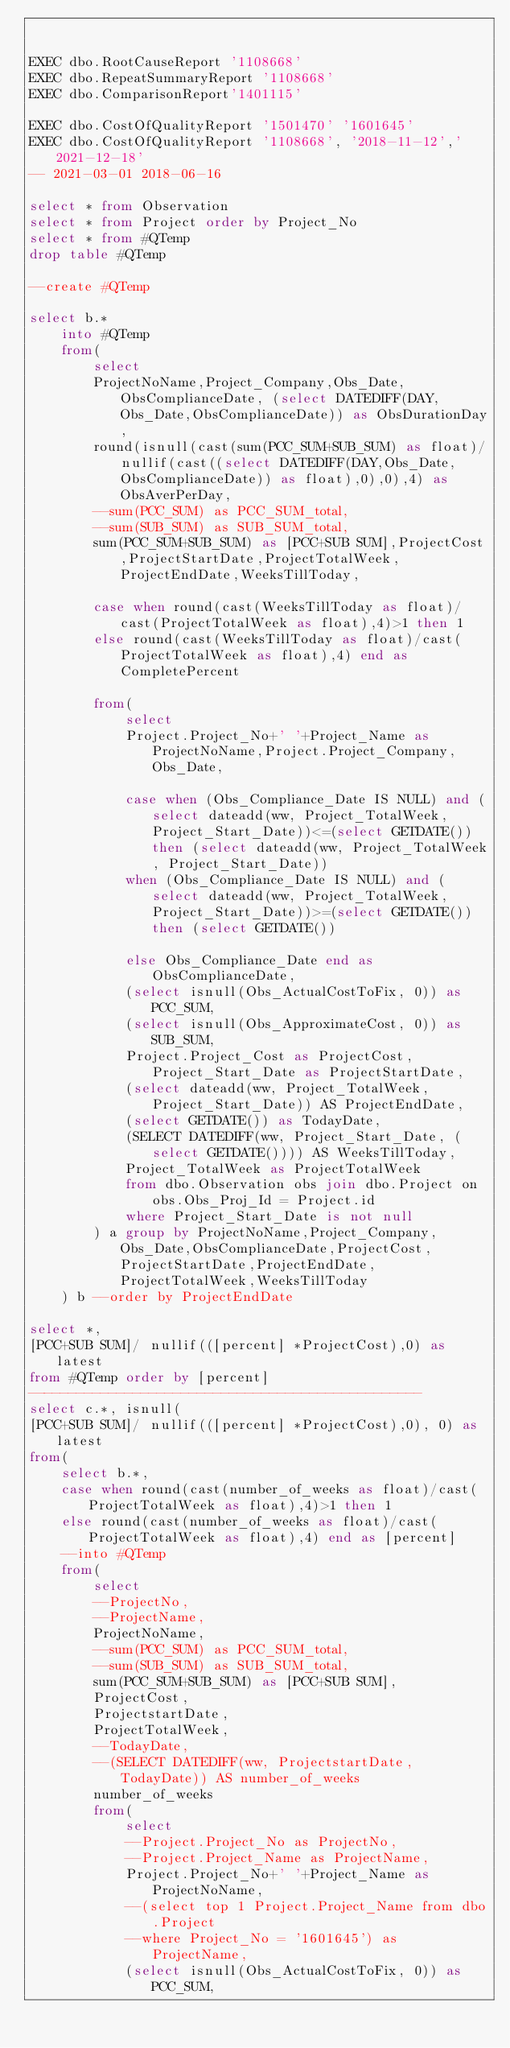<code> <loc_0><loc_0><loc_500><loc_500><_SQL_>

EXEC dbo.RootCauseReport '1108668'
EXEC dbo.RepeatSummaryReport '1108668'
EXEC dbo.ComparisonReport'1401115'

EXEC dbo.CostOfQualityReport '1501470' '1601645'
EXEC dbo.CostOfQualityReport '1108668', '2018-11-12','2021-12-18'
-- 2021-03-01 2018-06-16

select * from Observation
select * from Project order by Project_No
select * from #QTemp
drop table #QTemp

--create #QTemp

select b.*
	into #QTemp
	from(
		select 
		ProjectNoName,Project_Company,Obs_Date,ObsComplianceDate, (select DATEDIFF(DAY,Obs_Date,ObsComplianceDate)) as ObsDurationDay,
		round(isnull(cast(sum(PCC_SUM+SUB_SUM) as float)/nullif(cast((select DATEDIFF(DAY,Obs_Date,ObsComplianceDate)) as float),0),0),4) as ObsAverPerDay,
		--sum(PCC_SUM) as PCC_SUM_total,
		--sum(SUB_SUM) as SUB_SUM_total,
		sum(PCC_SUM+SUB_SUM) as [PCC+SUB SUM],ProjectCost,ProjectStartDate,ProjectTotalWeek,ProjectEndDate,WeeksTillToday,

		case when round(cast(WeeksTillToday as float)/cast(ProjectTotalWeek as float),4)>1 then 1
		else round(cast(WeeksTillToday as float)/cast(ProjectTotalWeek as float),4) end as CompletePercent

		from(
			select 
			Project.Project_No+' '+Project_Name as ProjectNoName,Project.Project_Company,Obs_Date,

			case when (Obs_Compliance_Date IS NULL) and (select dateadd(ww, Project_TotalWeek, Project_Start_Date))<=(select GETDATE()) then (select dateadd(ww, Project_TotalWeek, Project_Start_Date))
			when (Obs_Compliance_Date IS NULL) and (select dateadd(ww, Project_TotalWeek, Project_Start_Date))>=(select GETDATE()) then (select GETDATE())

			else Obs_Compliance_Date end as ObsComplianceDate,
			(select isnull(Obs_ActualCostToFix, 0)) as PCC_SUM,
			(select isnull(Obs_ApproximateCost, 0)) as SUB_SUM,
			Project.Project_Cost as ProjectCost,Project_Start_Date as ProjectStartDate,
			(select dateadd(ww, Project_TotalWeek, Project_Start_Date)) AS ProjectEndDate,
			(select GETDATE()) as TodayDate,
			(SELECT DATEDIFF(ww, Project_Start_Date, (select GETDATE()))) AS WeeksTillToday,
			Project_TotalWeek as ProjectTotalWeek
			from dbo.Observation obs join dbo.Project on obs.Obs_Proj_Id = Project.id
			where Project_Start_Date is not null
		) a group by ProjectNoName,Project_Company,Obs_Date,ObsComplianceDate,ProjectCost,ProjectStartDate,ProjectEndDate,ProjectTotalWeek,WeeksTillToday
	) b --order by ProjectEndDate

select *,
[PCC+SUB SUM]/ nullif(([percent] *ProjectCost),0) as latest
from #QTemp order by [percent]
-------------------------------------------------
select c.*, isnull(
[PCC+SUB SUM]/ nullif(([percent] *ProjectCost),0), 0) as latest
from(
	select b.*,
	case when round(cast(number_of_weeks as float)/cast(ProjectTotalWeek as float),4)>1 then 1
	else round(cast(number_of_weeks as float)/cast(ProjectTotalWeek as float),4) end as [percent]
	--into #QTemp
	from(
		select 
		--ProjectNo, 
		--ProjectName,
		ProjectNoName,
		--sum(PCC_SUM) as PCC_SUM_total,
		--sum(SUB_SUM) as SUB_SUM_total,
		sum(PCC_SUM+SUB_SUM) as [PCC+SUB SUM],
		ProjectCost,
		ProjectstartDate,
		ProjectTotalWeek,
		--TodayDate,
		--(SELECT DATEDIFF(ww, ProjectstartDate, TodayDate)) AS number_of_weeks
		number_of_weeks
		from(
			select 
			--Project.Project_No as ProjectNo, 
			--Project.Project_Name as ProjectName,
			Project.Project_No+' '+Project_Name as ProjectNoName,
			--(select top 1 Project.Project_Name from dbo.Project 
			--where Project_No = '1601645') as ProjectName,
			(select isnull(Obs_ActualCostToFix, 0)) as PCC_SUM,</code> 